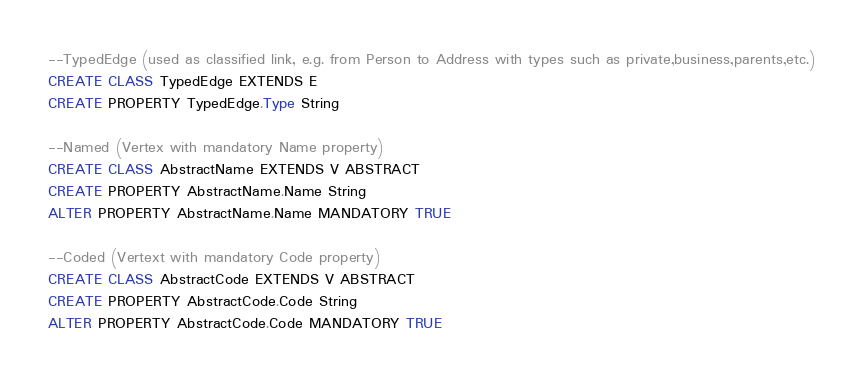<code> <loc_0><loc_0><loc_500><loc_500><_SQL_>--TypedEdge (used as classified link, e.g. from Person to Address with types such as private,business,parents,etc.)
CREATE CLASS TypedEdge EXTENDS E
CREATE PROPERTY TypedEdge.Type String

--Named (Vertex with mandatory Name property)
CREATE CLASS AbstractName EXTENDS V ABSTRACT
CREATE PROPERTY AbstractName.Name String
ALTER PROPERTY AbstractName.Name MANDATORY TRUE

--Coded (Vertext with mandatory Code property)
CREATE CLASS AbstractCode EXTENDS V ABSTRACT
CREATE PROPERTY AbstractCode.Code String
ALTER PROPERTY AbstractCode.Code MANDATORY TRUE
</code> 